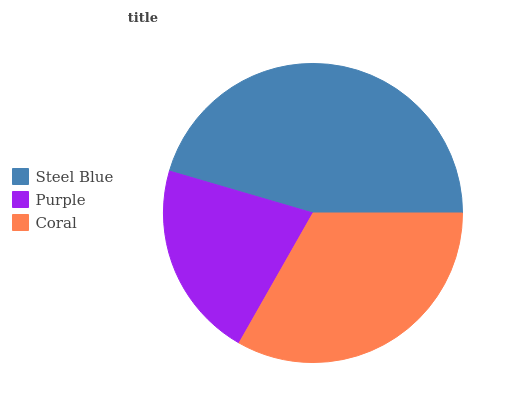Is Purple the minimum?
Answer yes or no. Yes. Is Steel Blue the maximum?
Answer yes or no. Yes. Is Coral the minimum?
Answer yes or no. No. Is Coral the maximum?
Answer yes or no. No. Is Coral greater than Purple?
Answer yes or no. Yes. Is Purple less than Coral?
Answer yes or no. Yes. Is Purple greater than Coral?
Answer yes or no. No. Is Coral less than Purple?
Answer yes or no. No. Is Coral the high median?
Answer yes or no. Yes. Is Coral the low median?
Answer yes or no. Yes. Is Steel Blue the high median?
Answer yes or no. No. Is Purple the low median?
Answer yes or no. No. 